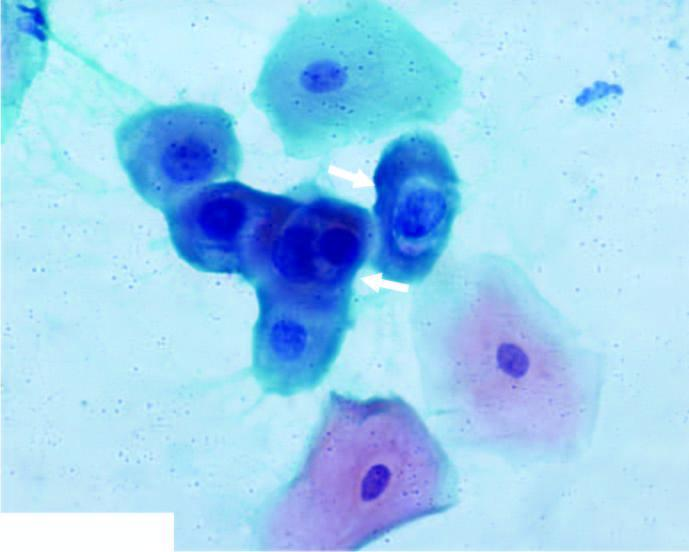does electron microscopy show koilocytes having abundant vacuolated cytoplasm and nuclear enlargement?
Answer the question using a single word or phrase. No 